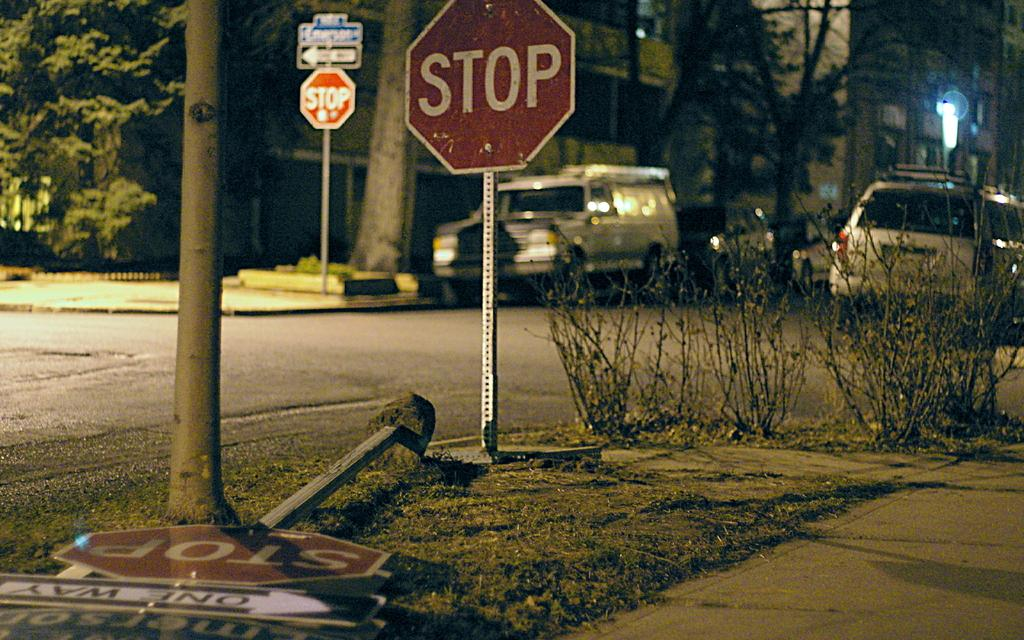<image>
Relay a brief, clear account of the picture shown. a stop sign that is outside with cars parked around it 